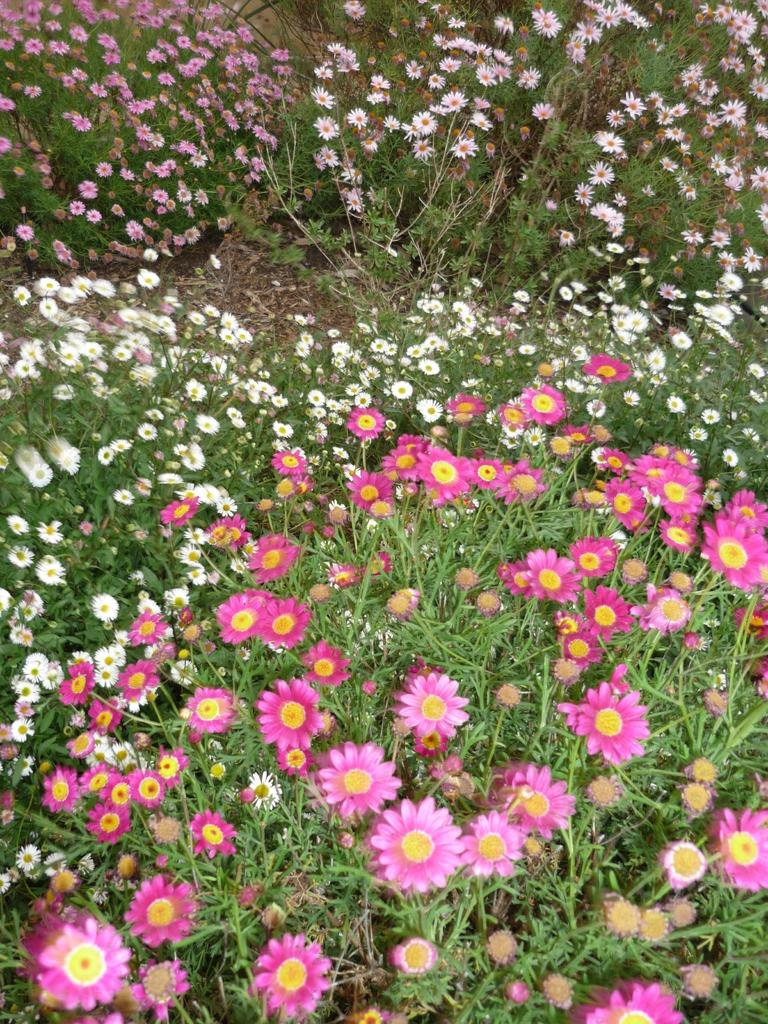What type of area is depicted in the image? There is a garden in the image. What can be found in the garden? The garden contains plants and flowers. What colors are the flowers in the garden? The flowers are in white and pink colors. What religion is practiced in the garden in the image? There is no indication of any religious practice in the garden in the image. How many flowers are present at the birth of the garden in the image? The image does not depict the birth of the garden, and therefore it is impossible to determine the number of flowers at that time. 